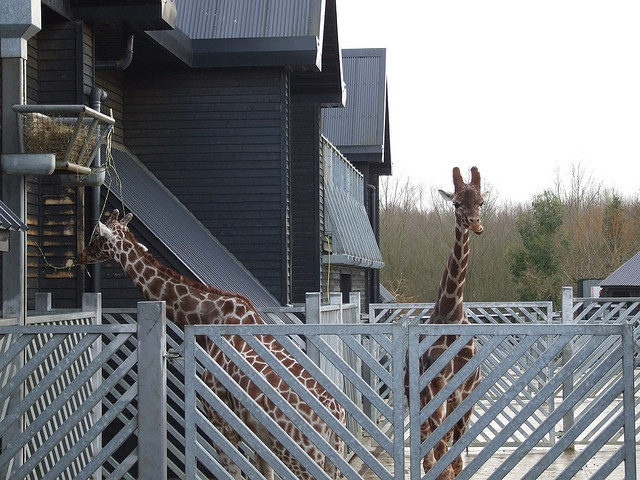Describe the objects in this image and their specific colors. I can see giraffe in gray, black, darkgray, and maroon tones and giraffe in gray, darkgray, and black tones in this image. 